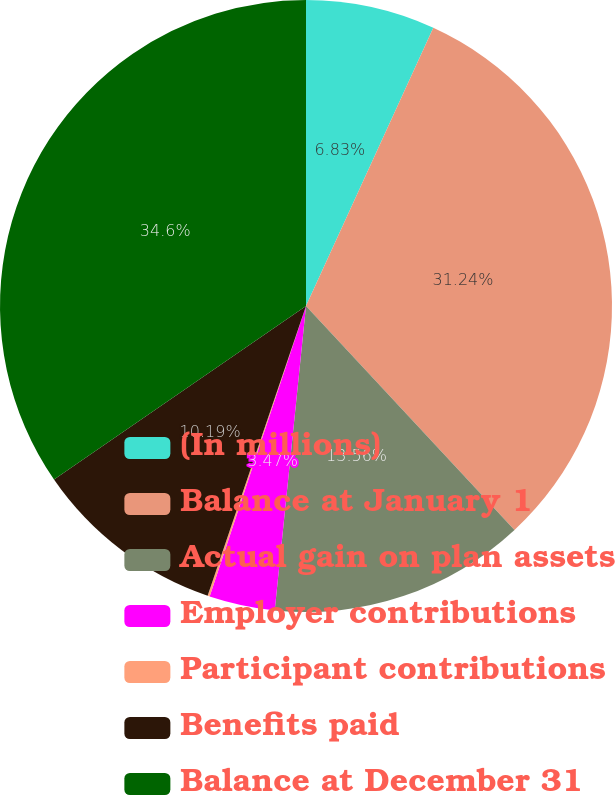Convert chart to OTSL. <chart><loc_0><loc_0><loc_500><loc_500><pie_chart><fcel>(In millions)<fcel>Balance at January 1<fcel>Actual gain on plan assets<fcel>Employer contributions<fcel>Participant contributions<fcel>Benefits paid<fcel>Balance at December 31<nl><fcel>6.83%<fcel>31.24%<fcel>13.56%<fcel>3.47%<fcel>0.11%<fcel>10.19%<fcel>34.6%<nl></chart> 